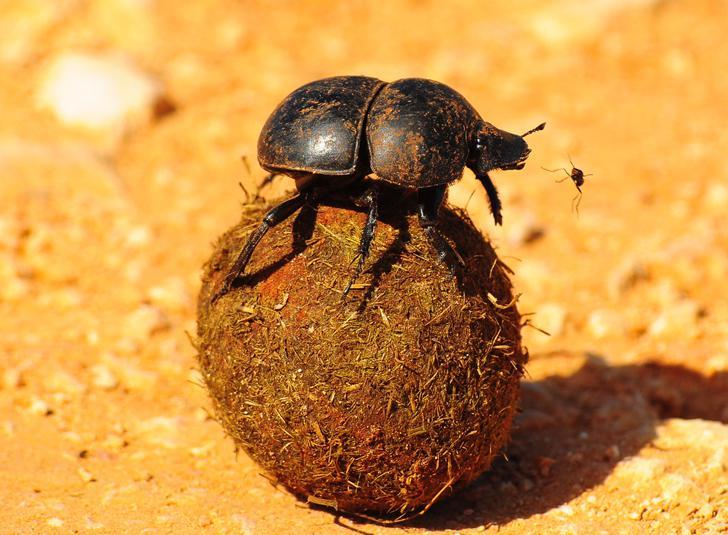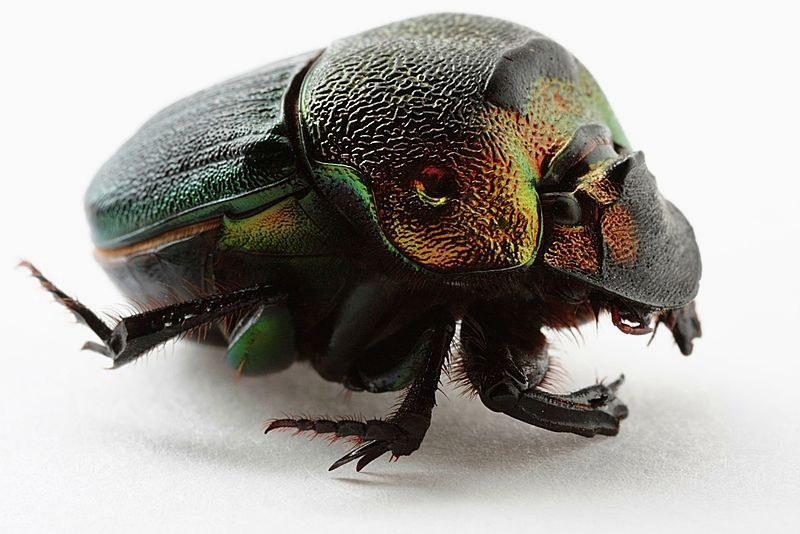The first image is the image on the left, the second image is the image on the right. For the images displayed, is the sentence "One dung beetle is completely on top of a piece of wood." factually correct? Answer yes or no. No. The first image is the image on the left, the second image is the image on the right. Analyze the images presented: Is the assertion "There are at least three beetles." valid? Answer yes or no. No. 